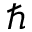<formula> <loc_0><loc_0><loc_500><loc_500>\hbar</formula> 